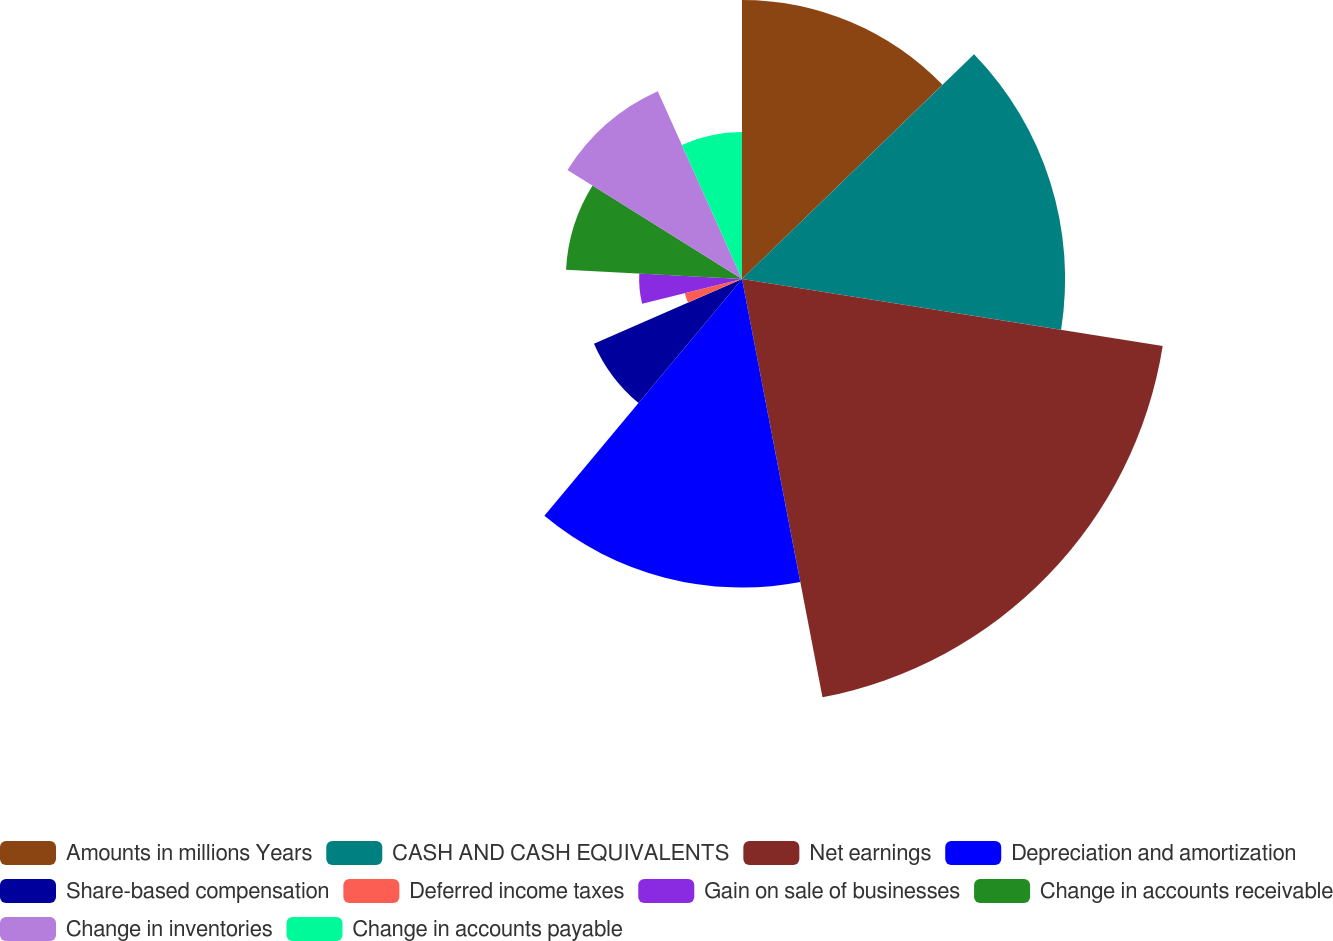Convert chart to OTSL. <chart><loc_0><loc_0><loc_500><loc_500><pie_chart><fcel>Amounts in millions Years<fcel>CASH AND CASH EQUIVALENTS<fcel>Net earnings<fcel>Depreciation and amortization<fcel>Share-based compensation<fcel>Deferred income taxes<fcel>Gain on sale of businesses<fcel>Change in accounts receivable<fcel>Change in inventories<fcel>Change in accounts payable<nl><fcel>12.75%<fcel>14.76%<fcel>19.46%<fcel>14.09%<fcel>7.38%<fcel>2.69%<fcel>4.7%<fcel>8.05%<fcel>9.4%<fcel>6.71%<nl></chart> 